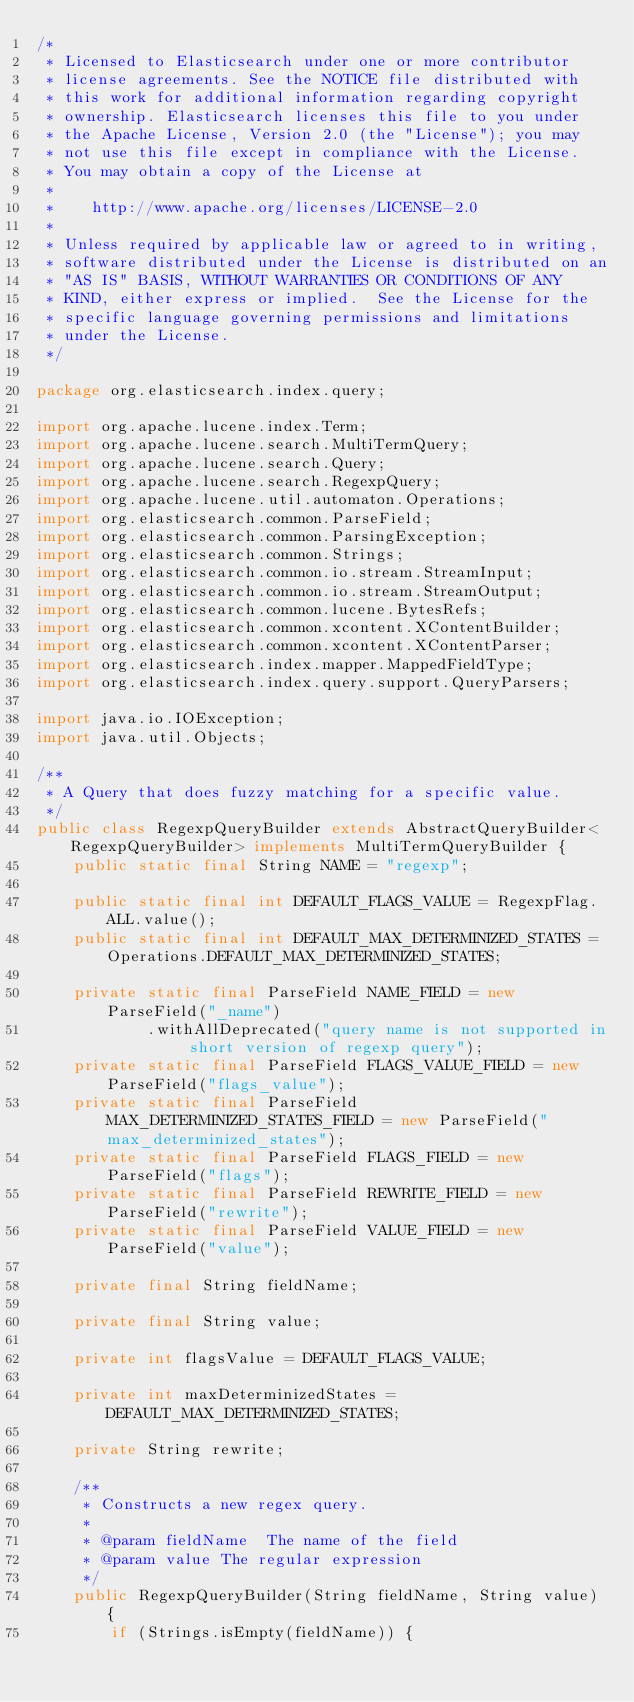<code> <loc_0><loc_0><loc_500><loc_500><_Java_>/*
 * Licensed to Elasticsearch under one or more contributor
 * license agreements. See the NOTICE file distributed with
 * this work for additional information regarding copyright
 * ownership. Elasticsearch licenses this file to you under
 * the Apache License, Version 2.0 (the "License"); you may
 * not use this file except in compliance with the License.
 * You may obtain a copy of the License at
 *
 *    http://www.apache.org/licenses/LICENSE-2.0
 *
 * Unless required by applicable law or agreed to in writing,
 * software distributed under the License is distributed on an
 * "AS IS" BASIS, WITHOUT WARRANTIES OR CONDITIONS OF ANY
 * KIND, either express or implied.  See the License for the
 * specific language governing permissions and limitations
 * under the License.
 */

package org.elasticsearch.index.query;

import org.apache.lucene.index.Term;
import org.apache.lucene.search.MultiTermQuery;
import org.apache.lucene.search.Query;
import org.apache.lucene.search.RegexpQuery;
import org.apache.lucene.util.automaton.Operations;
import org.elasticsearch.common.ParseField;
import org.elasticsearch.common.ParsingException;
import org.elasticsearch.common.Strings;
import org.elasticsearch.common.io.stream.StreamInput;
import org.elasticsearch.common.io.stream.StreamOutput;
import org.elasticsearch.common.lucene.BytesRefs;
import org.elasticsearch.common.xcontent.XContentBuilder;
import org.elasticsearch.common.xcontent.XContentParser;
import org.elasticsearch.index.mapper.MappedFieldType;
import org.elasticsearch.index.query.support.QueryParsers;

import java.io.IOException;
import java.util.Objects;

/**
 * A Query that does fuzzy matching for a specific value.
 */
public class RegexpQueryBuilder extends AbstractQueryBuilder<RegexpQueryBuilder> implements MultiTermQueryBuilder {
    public static final String NAME = "regexp";

    public static final int DEFAULT_FLAGS_VALUE = RegexpFlag.ALL.value();
    public static final int DEFAULT_MAX_DETERMINIZED_STATES = Operations.DEFAULT_MAX_DETERMINIZED_STATES;

    private static final ParseField NAME_FIELD = new ParseField("_name")
            .withAllDeprecated("query name is not supported in short version of regexp query");
    private static final ParseField FLAGS_VALUE_FIELD = new ParseField("flags_value");
    private static final ParseField MAX_DETERMINIZED_STATES_FIELD = new ParseField("max_determinized_states");
    private static final ParseField FLAGS_FIELD = new ParseField("flags");
    private static final ParseField REWRITE_FIELD = new ParseField("rewrite");
    private static final ParseField VALUE_FIELD = new ParseField("value");

    private final String fieldName;

    private final String value;

    private int flagsValue = DEFAULT_FLAGS_VALUE;

    private int maxDeterminizedStates = DEFAULT_MAX_DETERMINIZED_STATES;

    private String rewrite;

    /**
     * Constructs a new regex query.
     *
     * @param fieldName  The name of the field
     * @param value The regular expression
     */
    public RegexpQueryBuilder(String fieldName, String value) {
        if (Strings.isEmpty(fieldName)) {</code> 